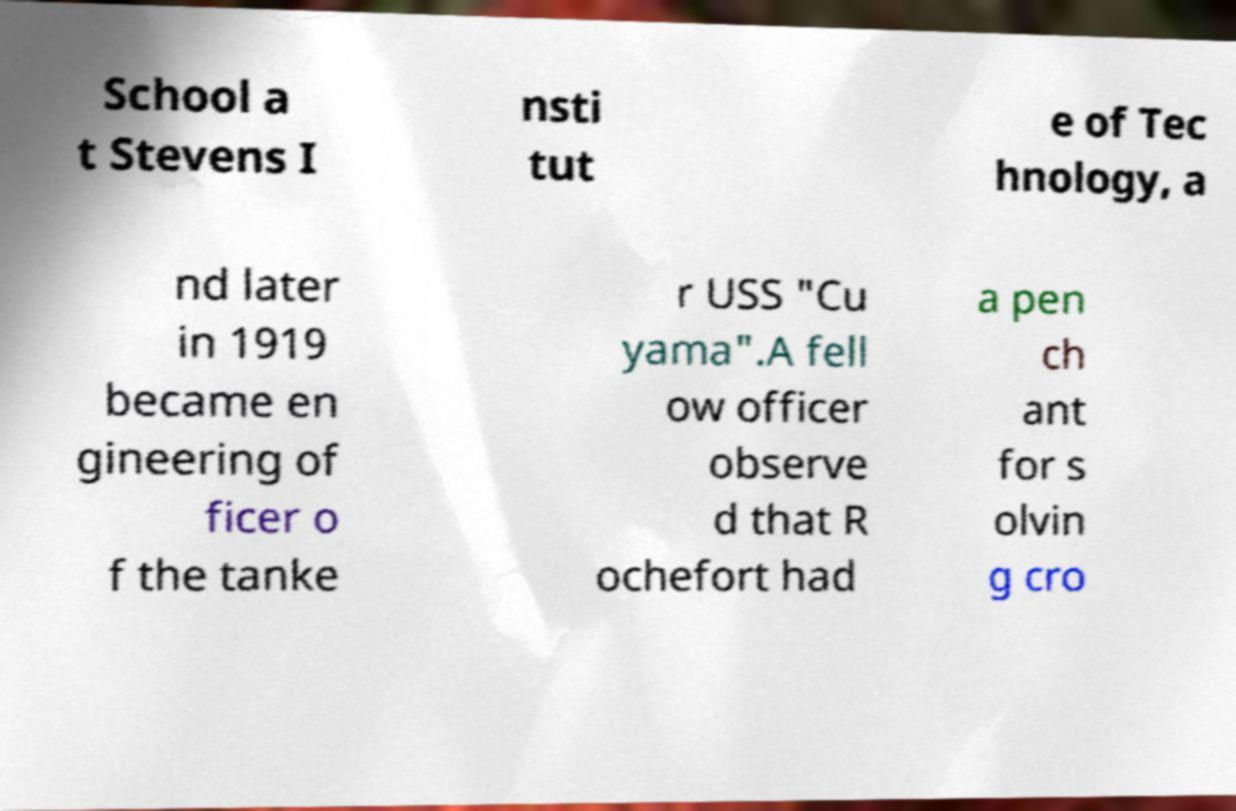Please read and relay the text visible in this image. What does it say? School a t Stevens I nsti tut e of Tec hnology, a nd later in 1919 became en gineering of ficer o f the tanke r USS "Cu yama".A fell ow officer observe d that R ochefort had a pen ch ant for s olvin g cro 